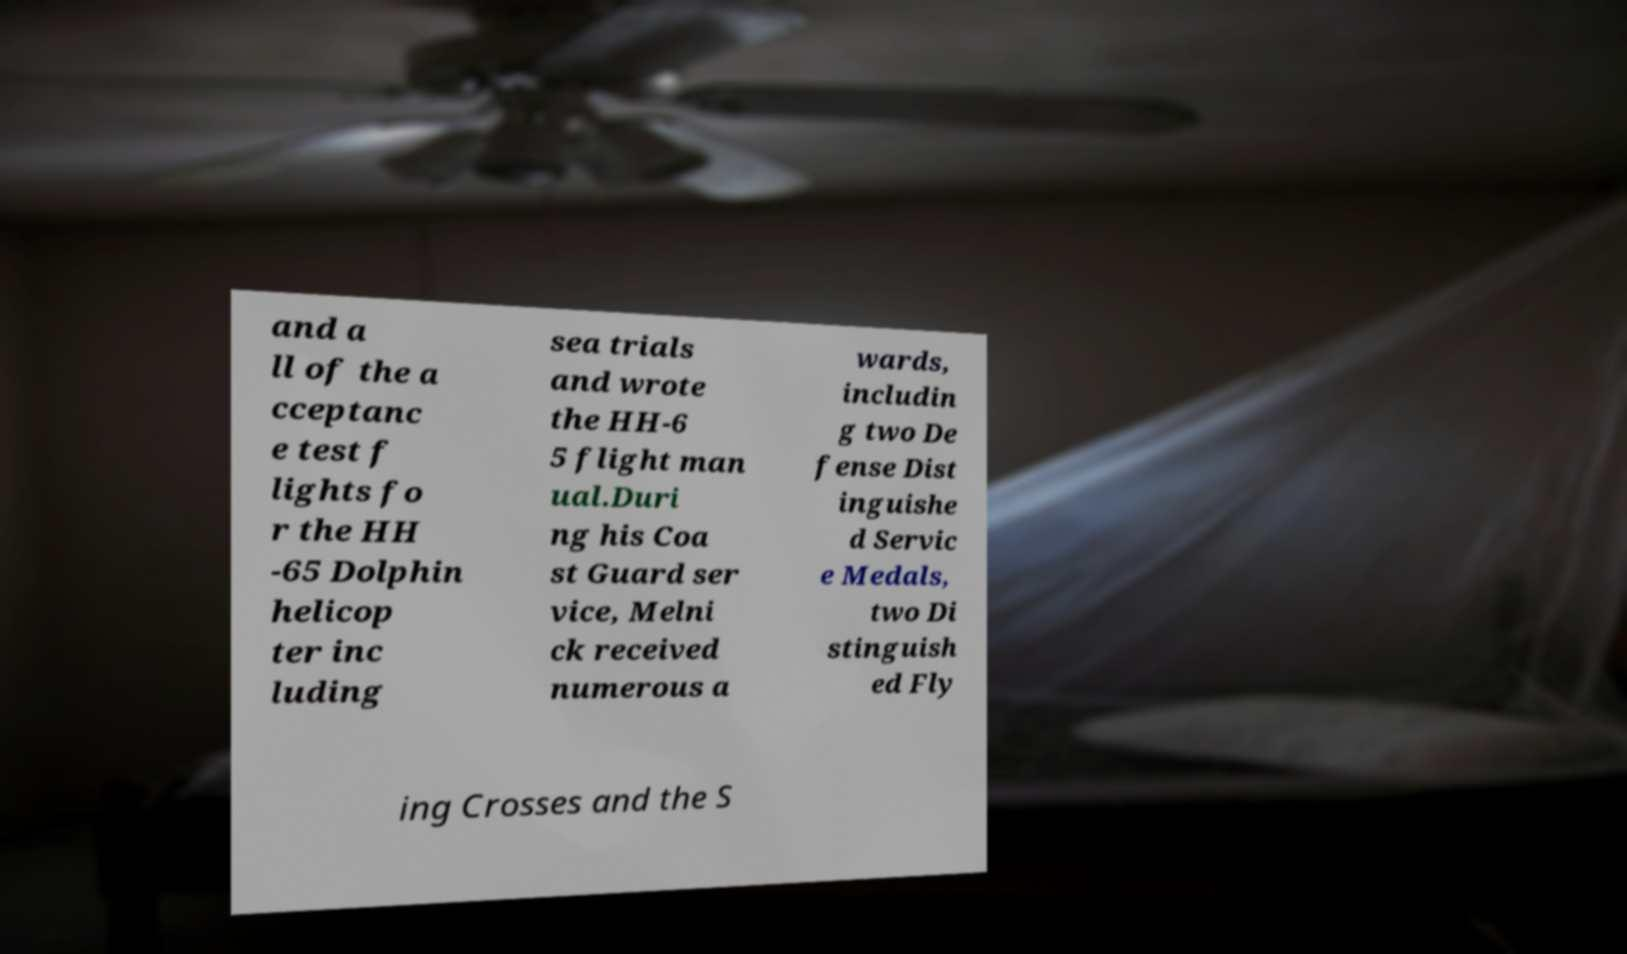For documentation purposes, I need the text within this image transcribed. Could you provide that? and a ll of the a cceptanc e test f lights fo r the HH -65 Dolphin helicop ter inc luding sea trials and wrote the HH-6 5 flight man ual.Duri ng his Coa st Guard ser vice, Melni ck received numerous a wards, includin g two De fense Dist inguishe d Servic e Medals, two Di stinguish ed Fly ing Crosses and the S 